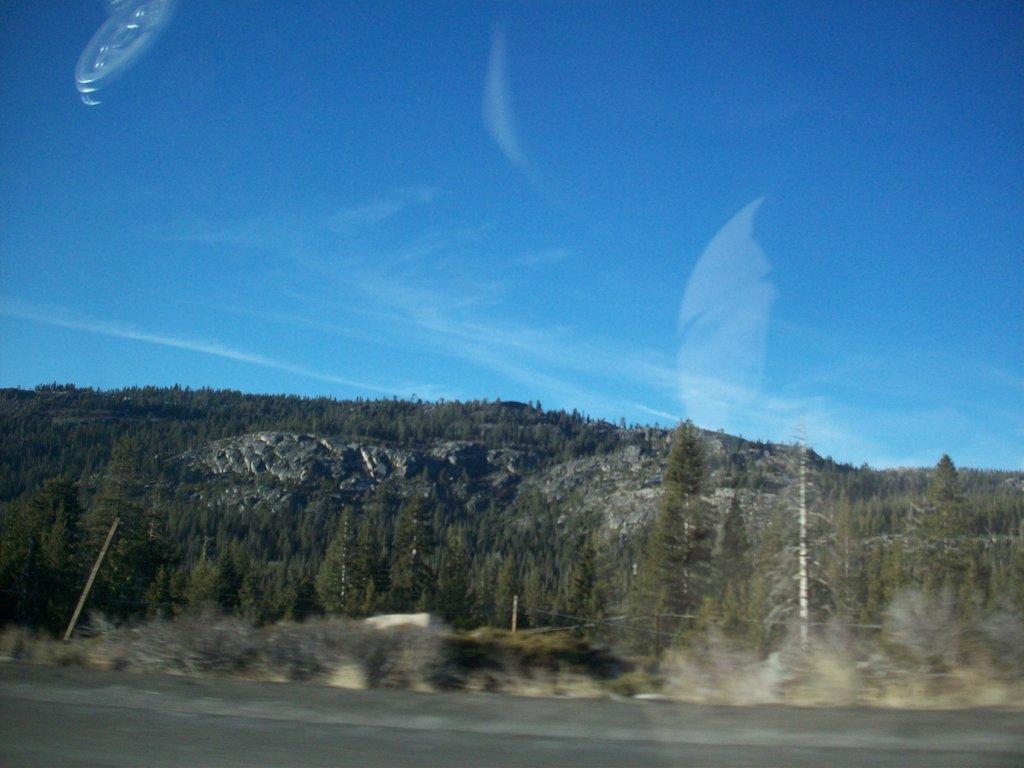Can you describe this image briefly? In this image I can see there is a picture with the reflection. And there is a road. At the back there is a mountain and a tree. And at the top there is a sky. 